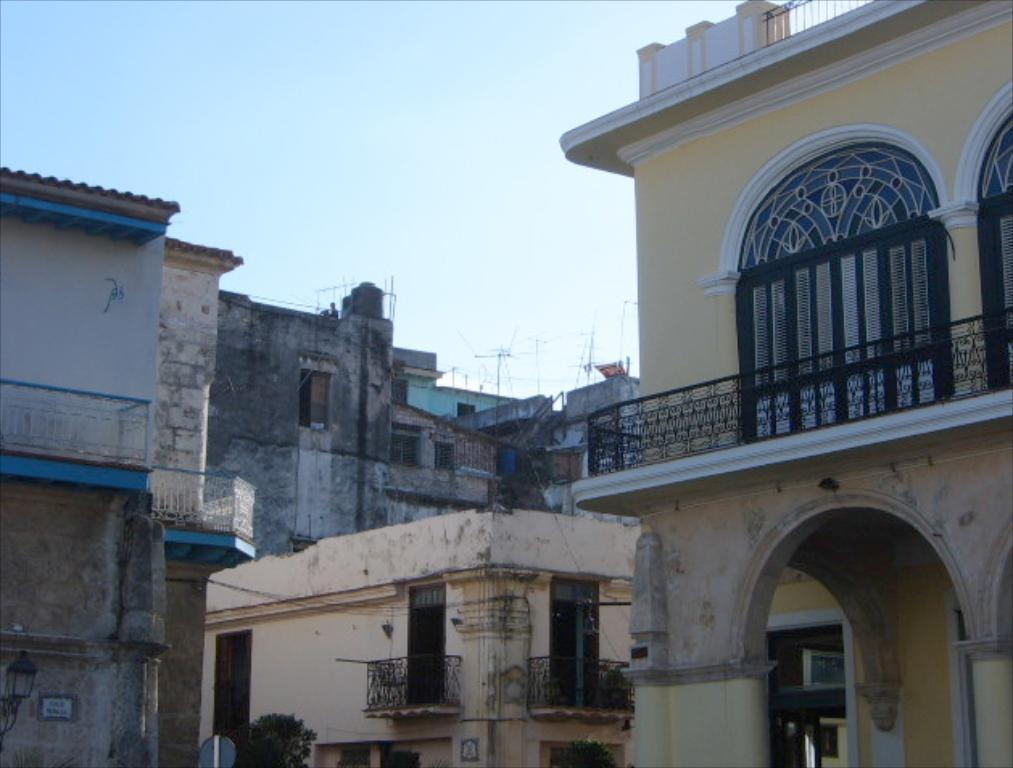What type of structures can be seen in the image? There are buildings in the image. Can you describe the vegetation present in the image? There is a tree in front of one of the buildings. What type of skin condition can be seen on the tree in the image? There is no mention of a skin condition or any medical issue related to the tree in the image. 